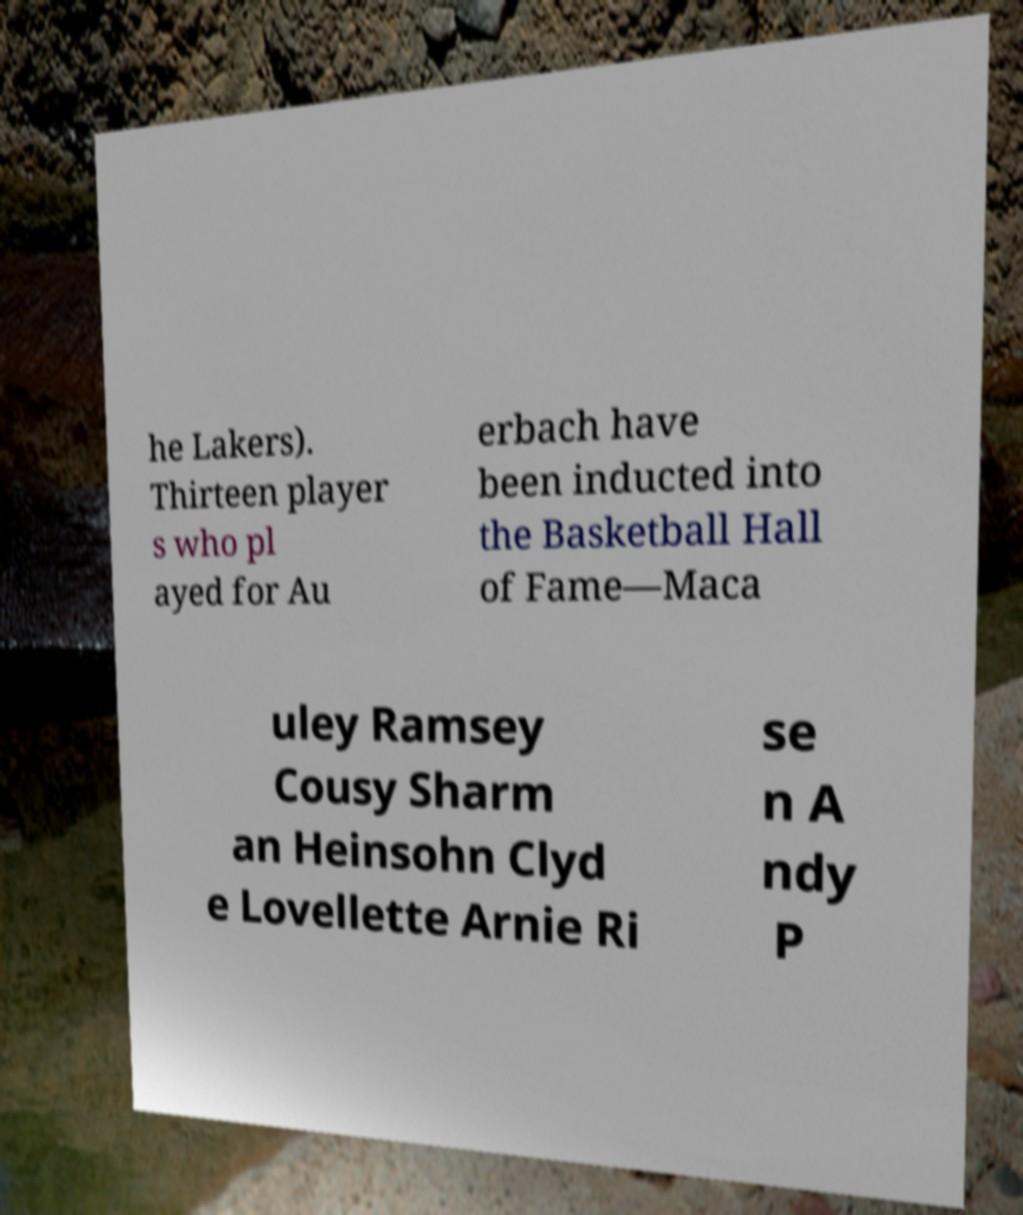Please identify and transcribe the text found in this image. he Lakers). Thirteen player s who pl ayed for Au erbach have been inducted into the Basketball Hall of Fame—Maca uley Ramsey Cousy Sharm an Heinsohn Clyd e Lovellette Arnie Ri se n A ndy P 